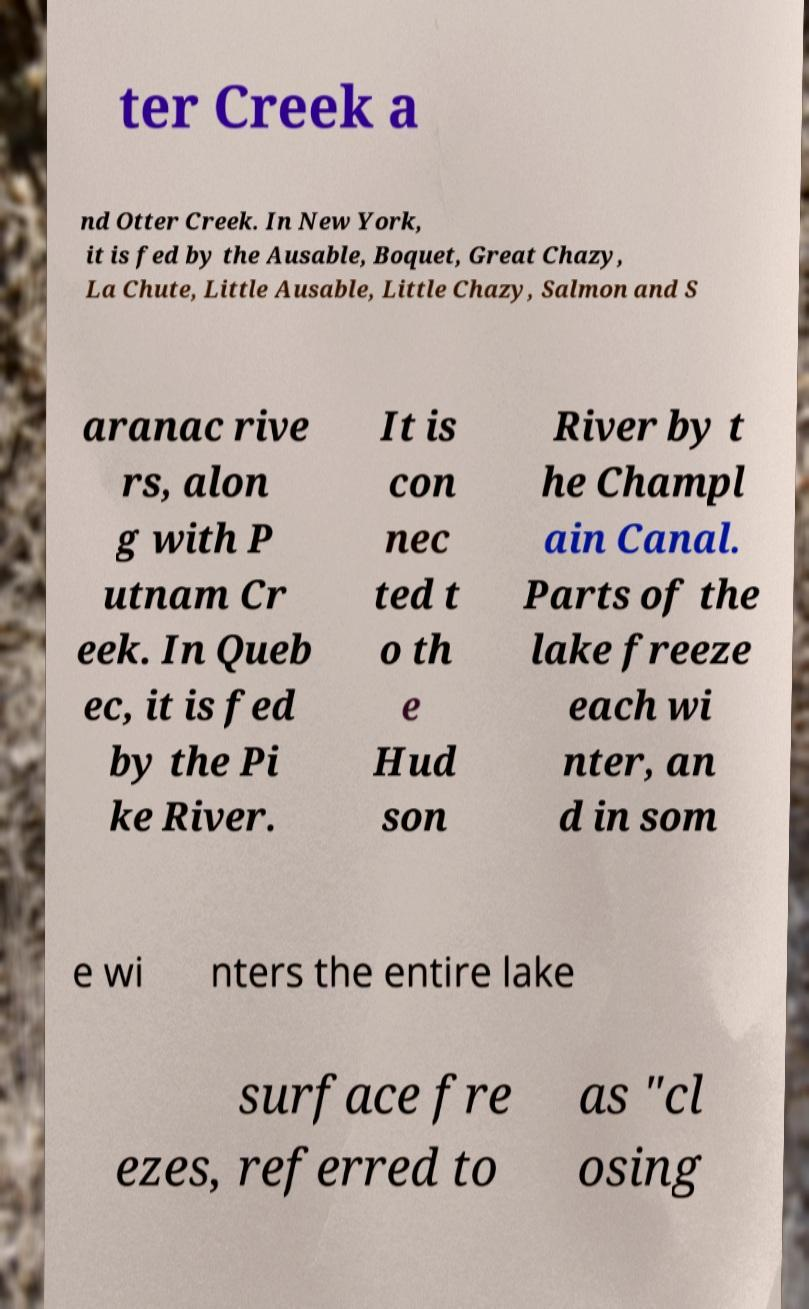What messages or text are displayed in this image? I need them in a readable, typed format. ter Creek a nd Otter Creek. In New York, it is fed by the Ausable, Boquet, Great Chazy, La Chute, Little Ausable, Little Chazy, Salmon and S aranac rive rs, alon g with P utnam Cr eek. In Queb ec, it is fed by the Pi ke River. It is con nec ted t o th e Hud son River by t he Champl ain Canal. Parts of the lake freeze each wi nter, an d in som e wi nters the entire lake surface fre ezes, referred to as "cl osing 